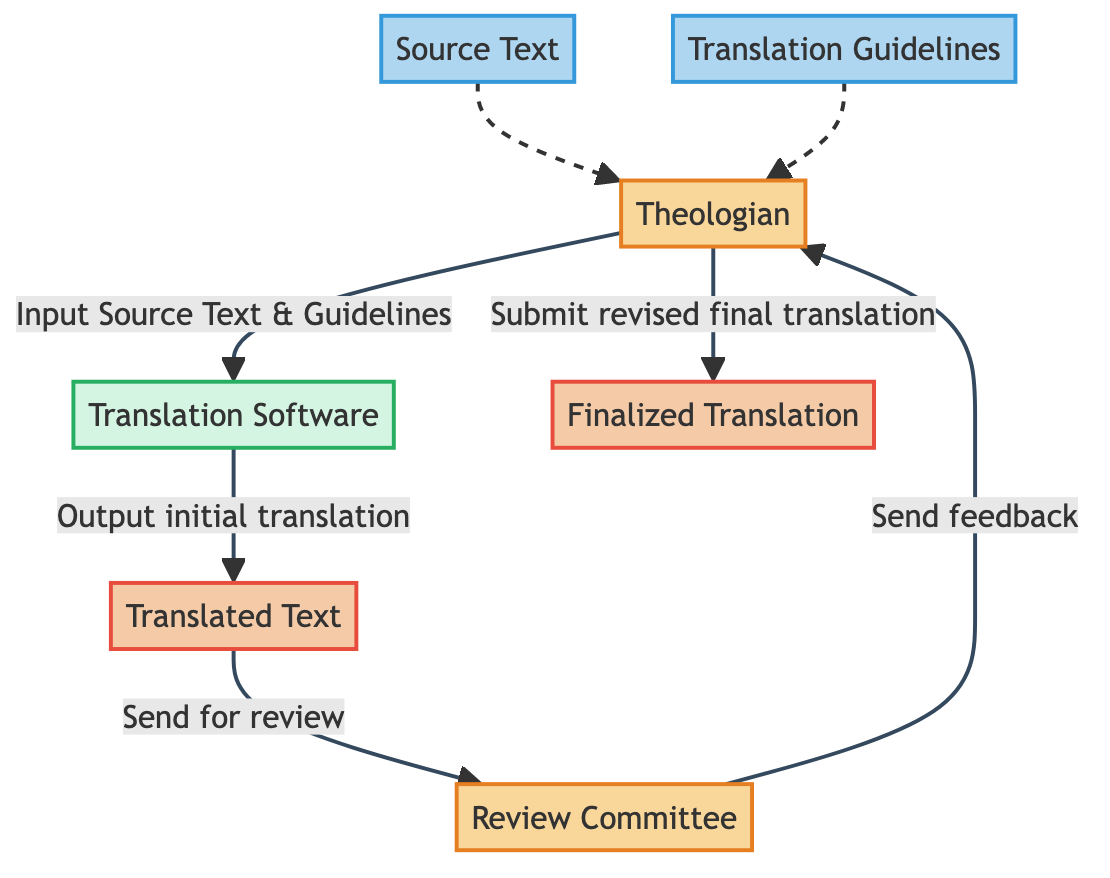What is the final output of the workflow? The final output of the workflow is stored in the "Finalized Translation" node, which contains the approved and finalized translated text after revisions.
Answer: Finalized Translation How many external entities are present in the diagram? There are two external entities in the diagram: "Theologian" and "Review Committee".
Answer: 2 What does the "Translation Software" process output? The output of the "Translation Software" process is the "Translated Text", which is the initial translated version of the German Protestant texts.
Answer: Translated Text Who sends feedback to the theologian? The "Review Committee" sends feedback to the "Theologian" after reviewing the translated text.
Answer: Review Committee What is the first input to the "Translation Software"? The first input to the "Translation Software" is both the "Source Text" and the "Translation Guidelines" provided by the "Theologian".
Answer: Source Text and Translation Guidelines What does the "Translated Text" flow to after its creation? After its creation, the "Translated Text" flows to the "Review Committee" for review.
Answer: Review Committee How many data sources are listed in the diagram? There are two data sources listed in the diagram: "Source Text" and "Translation Guidelines".
Answer: 2 What is the relationship between "Review Committee" and "Finalized Translation"? The "Review Committee" does not directly interact with the "Finalized Translation", but it sends feedback to the "Theologian", who then submits the revised text to create the "Finalized Translation".
Answer: Indirect relationship through feedback What type of feedback does the Theologian receive? The feedback the Theologian receives from the "Review Committee" is referred to as "Translation Feedback".
Answer: Translation Feedback 